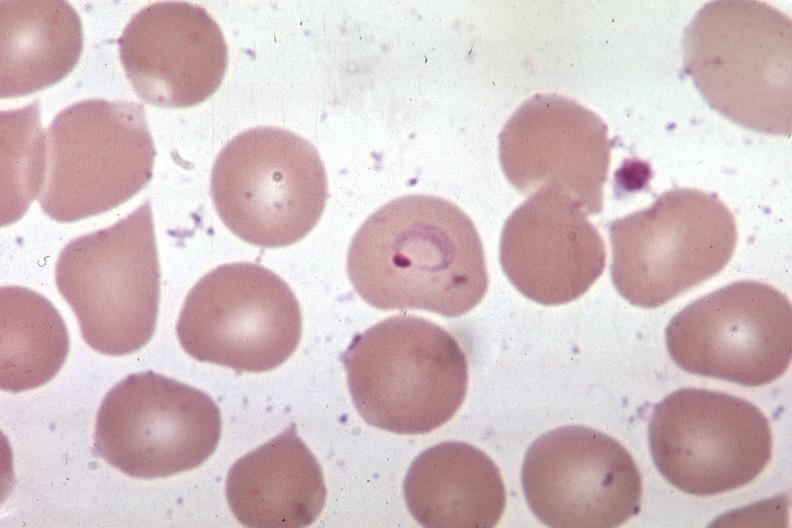what does this image show?
Answer the question using a single word or phrase. Wrights excellent 